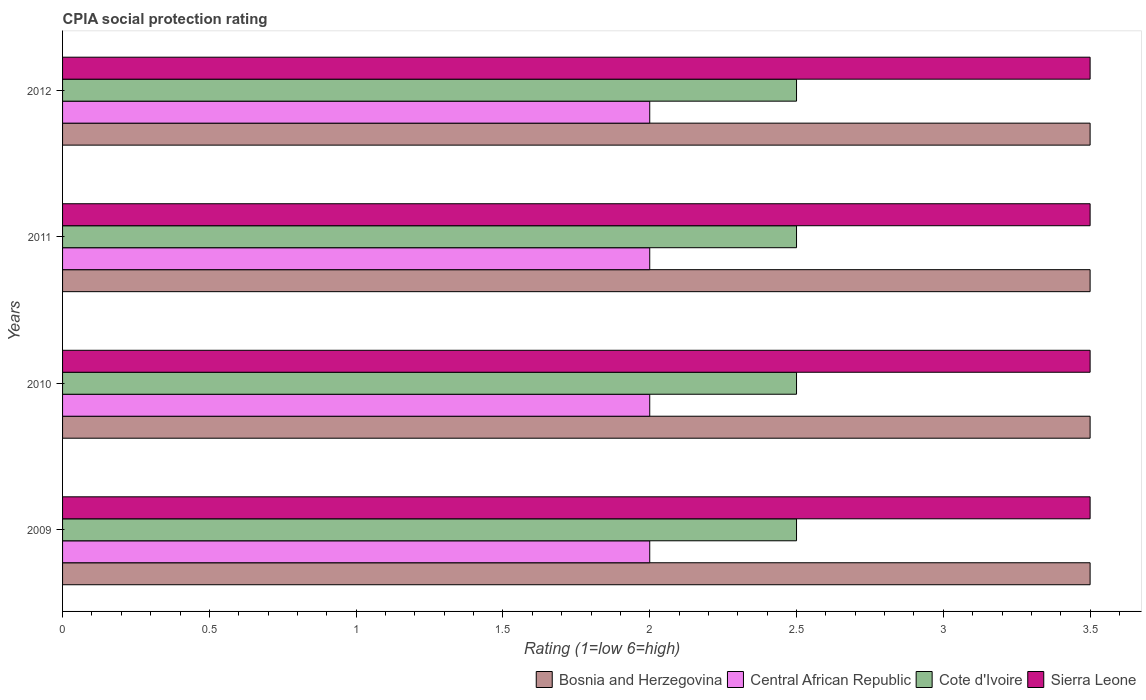Are the number of bars per tick equal to the number of legend labels?
Provide a succinct answer. Yes. Are the number of bars on each tick of the Y-axis equal?
Offer a terse response. Yes. How many bars are there on the 2nd tick from the bottom?
Provide a succinct answer. 4. Across all years, what is the maximum CPIA rating in Sierra Leone?
Your response must be concise. 3.5. Across all years, what is the minimum CPIA rating in Cote d'Ivoire?
Your answer should be compact. 2.5. In which year was the CPIA rating in Sierra Leone maximum?
Offer a terse response. 2009. What is the total CPIA rating in Bosnia and Herzegovina in the graph?
Your answer should be compact. 14. What is the difference between the CPIA rating in Cote d'Ivoire in 2010 and that in 2011?
Make the answer very short. 0. What is the difference between the CPIA rating in Sierra Leone in 2010 and the CPIA rating in Bosnia and Herzegovina in 2012?
Keep it short and to the point. 0. In the year 2009, what is the difference between the CPIA rating in Cote d'Ivoire and CPIA rating in Central African Republic?
Offer a very short reply. 0.5. In how many years, is the CPIA rating in Bosnia and Herzegovina greater than 1 ?
Your answer should be very brief. 4. Is the CPIA rating in Cote d'Ivoire in 2010 less than that in 2012?
Provide a short and direct response. No. Is the difference between the CPIA rating in Cote d'Ivoire in 2009 and 2010 greater than the difference between the CPIA rating in Central African Republic in 2009 and 2010?
Your response must be concise. No. What is the difference between the highest and the second highest CPIA rating in Cote d'Ivoire?
Keep it short and to the point. 0. What does the 1st bar from the top in 2012 represents?
Your answer should be very brief. Sierra Leone. What does the 3rd bar from the bottom in 2010 represents?
Offer a very short reply. Cote d'Ivoire. Is it the case that in every year, the sum of the CPIA rating in Central African Republic and CPIA rating in Sierra Leone is greater than the CPIA rating in Bosnia and Herzegovina?
Provide a succinct answer. Yes. Are all the bars in the graph horizontal?
Give a very brief answer. Yes. How many years are there in the graph?
Offer a terse response. 4. What is the difference between two consecutive major ticks on the X-axis?
Keep it short and to the point. 0.5. Are the values on the major ticks of X-axis written in scientific E-notation?
Your response must be concise. No. Does the graph contain any zero values?
Keep it short and to the point. No. How are the legend labels stacked?
Your answer should be compact. Horizontal. What is the title of the graph?
Your response must be concise. CPIA social protection rating. What is the label or title of the X-axis?
Your answer should be very brief. Rating (1=low 6=high). What is the Rating (1=low 6=high) in Cote d'Ivoire in 2009?
Your answer should be very brief. 2.5. What is the Rating (1=low 6=high) of Sierra Leone in 2009?
Your answer should be compact. 3.5. What is the Rating (1=low 6=high) in Bosnia and Herzegovina in 2010?
Provide a short and direct response. 3.5. What is the Rating (1=low 6=high) in Cote d'Ivoire in 2010?
Provide a succinct answer. 2.5. What is the Rating (1=low 6=high) of Cote d'Ivoire in 2011?
Make the answer very short. 2.5. What is the Rating (1=low 6=high) in Central African Republic in 2012?
Ensure brevity in your answer.  2. Across all years, what is the minimum Rating (1=low 6=high) of Bosnia and Herzegovina?
Give a very brief answer. 3.5. Across all years, what is the minimum Rating (1=low 6=high) of Central African Republic?
Keep it short and to the point. 2. Across all years, what is the minimum Rating (1=low 6=high) of Cote d'Ivoire?
Provide a succinct answer. 2.5. What is the total Rating (1=low 6=high) in Central African Republic in the graph?
Give a very brief answer. 8. What is the total Rating (1=low 6=high) in Cote d'Ivoire in the graph?
Keep it short and to the point. 10. What is the difference between the Rating (1=low 6=high) in Bosnia and Herzegovina in 2009 and that in 2010?
Provide a short and direct response. 0. What is the difference between the Rating (1=low 6=high) in Central African Republic in 2009 and that in 2010?
Your answer should be compact. 0. What is the difference between the Rating (1=low 6=high) of Cote d'Ivoire in 2009 and that in 2010?
Keep it short and to the point. 0. What is the difference between the Rating (1=low 6=high) of Sierra Leone in 2009 and that in 2010?
Provide a short and direct response. 0. What is the difference between the Rating (1=low 6=high) in Cote d'Ivoire in 2009 and that in 2011?
Ensure brevity in your answer.  0. What is the difference between the Rating (1=low 6=high) of Sierra Leone in 2009 and that in 2011?
Make the answer very short. 0. What is the difference between the Rating (1=low 6=high) of Central African Republic in 2009 and that in 2012?
Your response must be concise. 0. What is the difference between the Rating (1=low 6=high) of Cote d'Ivoire in 2009 and that in 2012?
Your answer should be very brief. 0. What is the difference between the Rating (1=low 6=high) of Cote d'Ivoire in 2010 and that in 2011?
Keep it short and to the point. 0. What is the difference between the Rating (1=low 6=high) of Cote d'Ivoire in 2010 and that in 2012?
Provide a succinct answer. 0. What is the difference between the Rating (1=low 6=high) of Sierra Leone in 2010 and that in 2012?
Ensure brevity in your answer.  0. What is the difference between the Rating (1=low 6=high) in Central African Republic in 2011 and that in 2012?
Your response must be concise. 0. What is the difference between the Rating (1=low 6=high) in Bosnia and Herzegovina in 2009 and the Rating (1=low 6=high) in Central African Republic in 2010?
Your response must be concise. 1.5. What is the difference between the Rating (1=low 6=high) in Bosnia and Herzegovina in 2009 and the Rating (1=low 6=high) in Cote d'Ivoire in 2010?
Your answer should be compact. 1. What is the difference between the Rating (1=low 6=high) of Central African Republic in 2009 and the Rating (1=low 6=high) of Sierra Leone in 2010?
Keep it short and to the point. -1.5. What is the difference between the Rating (1=low 6=high) in Bosnia and Herzegovina in 2009 and the Rating (1=low 6=high) in Sierra Leone in 2011?
Your response must be concise. 0. What is the difference between the Rating (1=low 6=high) in Central African Republic in 2009 and the Rating (1=low 6=high) in Sierra Leone in 2011?
Offer a very short reply. -1.5. What is the difference between the Rating (1=low 6=high) in Cote d'Ivoire in 2009 and the Rating (1=low 6=high) in Sierra Leone in 2011?
Keep it short and to the point. -1. What is the difference between the Rating (1=low 6=high) of Bosnia and Herzegovina in 2009 and the Rating (1=low 6=high) of Sierra Leone in 2012?
Provide a short and direct response. 0. What is the difference between the Rating (1=low 6=high) in Central African Republic in 2009 and the Rating (1=low 6=high) in Cote d'Ivoire in 2012?
Offer a terse response. -0.5. What is the difference between the Rating (1=low 6=high) in Cote d'Ivoire in 2009 and the Rating (1=low 6=high) in Sierra Leone in 2012?
Ensure brevity in your answer.  -1. What is the difference between the Rating (1=low 6=high) in Bosnia and Herzegovina in 2010 and the Rating (1=low 6=high) in Cote d'Ivoire in 2011?
Your answer should be compact. 1. What is the difference between the Rating (1=low 6=high) of Bosnia and Herzegovina in 2010 and the Rating (1=low 6=high) of Sierra Leone in 2011?
Your response must be concise. 0. What is the difference between the Rating (1=low 6=high) of Central African Republic in 2010 and the Rating (1=low 6=high) of Cote d'Ivoire in 2011?
Ensure brevity in your answer.  -0.5. What is the difference between the Rating (1=low 6=high) of Central African Republic in 2010 and the Rating (1=low 6=high) of Sierra Leone in 2011?
Your answer should be very brief. -1.5. What is the difference between the Rating (1=low 6=high) of Central African Republic in 2010 and the Rating (1=low 6=high) of Cote d'Ivoire in 2012?
Keep it short and to the point. -0.5. What is the difference between the Rating (1=low 6=high) of Bosnia and Herzegovina in 2011 and the Rating (1=low 6=high) of Central African Republic in 2012?
Make the answer very short. 1.5. What is the difference between the Rating (1=low 6=high) in Bosnia and Herzegovina in 2011 and the Rating (1=low 6=high) in Cote d'Ivoire in 2012?
Offer a very short reply. 1. What is the difference between the Rating (1=low 6=high) of Central African Republic in 2011 and the Rating (1=low 6=high) of Cote d'Ivoire in 2012?
Give a very brief answer. -0.5. What is the difference between the Rating (1=low 6=high) in Cote d'Ivoire in 2011 and the Rating (1=low 6=high) in Sierra Leone in 2012?
Provide a succinct answer. -1. What is the average Rating (1=low 6=high) of Central African Republic per year?
Your answer should be very brief. 2. In the year 2009, what is the difference between the Rating (1=low 6=high) in Bosnia and Herzegovina and Rating (1=low 6=high) in Central African Republic?
Provide a short and direct response. 1.5. In the year 2009, what is the difference between the Rating (1=low 6=high) in Bosnia and Herzegovina and Rating (1=low 6=high) in Sierra Leone?
Ensure brevity in your answer.  0. In the year 2009, what is the difference between the Rating (1=low 6=high) in Central African Republic and Rating (1=low 6=high) in Cote d'Ivoire?
Make the answer very short. -0.5. In the year 2009, what is the difference between the Rating (1=low 6=high) of Central African Republic and Rating (1=low 6=high) of Sierra Leone?
Your response must be concise. -1.5. In the year 2010, what is the difference between the Rating (1=low 6=high) of Bosnia and Herzegovina and Rating (1=low 6=high) of Central African Republic?
Provide a short and direct response. 1.5. In the year 2010, what is the difference between the Rating (1=low 6=high) in Bosnia and Herzegovina and Rating (1=low 6=high) in Cote d'Ivoire?
Offer a very short reply. 1. In the year 2010, what is the difference between the Rating (1=low 6=high) in Cote d'Ivoire and Rating (1=low 6=high) in Sierra Leone?
Make the answer very short. -1. In the year 2011, what is the difference between the Rating (1=low 6=high) of Bosnia and Herzegovina and Rating (1=low 6=high) of Central African Republic?
Ensure brevity in your answer.  1.5. In the year 2011, what is the difference between the Rating (1=low 6=high) in Bosnia and Herzegovina and Rating (1=low 6=high) in Cote d'Ivoire?
Provide a succinct answer. 1. In the year 2012, what is the difference between the Rating (1=low 6=high) of Bosnia and Herzegovina and Rating (1=low 6=high) of Central African Republic?
Ensure brevity in your answer.  1.5. In the year 2012, what is the difference between the Rating (1=low 6=high) of Central African Republic and Rating (1=low 6=high) of Sierra Leone?
Offer a terse response. -1.5. In the year 2012, what is the difference between the Rating (1=low 6=high) in Cote d'Ivoire and Rating (1=low 6=high) in Sierra Leone?
Make the answer very short. -1. What is the ratio of the Rating (1=low 6=high) in Bosnia and Herzegovina in 2009 to that in 2011?
Your answer should be very brief. 1. What is the ratio of the Rating (1=low 6=high) in Sierra Leone in 2009 to that in 2011?
Offer a very short reply. 1. What is the ratio of the Rating (1=low 6=high) in Central African Republic in 2010 to that in 2012?
Provide a short and direct response. 1. What is the ratio of the Rating (1=low 6=high) of Cote d'Ivoire in 2010 to that in 2012?
Offer a terse response. 1. What is the ratio of the Rating (1=low 6=high) of Sierra Leone in 2010 to that in 2012?
Your answer should be compact. 1. What is the ratio of the Rating (1=low 6=high) in Bosnia and Herzegovina in 2011 to that in 2012?
Provide a short and direct response. 1. What is the ratio of the Rating (1=low 6=high) of Cote d'Ivoire in 2011 to that in 2012?
Give a very brief answer. 1. What is the ratio of the Rating (1=low 6=high) of Sierra Leone in 2011 to that in 2012?
Your answer should be very brief. 1. What is the difference between the highest and the second highest Rating (1=low 6=high) of Central African Republic?
Keep it short and to the point. 0. What is the difference between the highest and the second highest Rating (1=low 6=high) of Cote d'Ivoire?
Offer a terse response. 0. What is the difference between the highest and the second highest Rating (1=low 6=high) in Sierra Leone?
Give a very brief answer. 0. What is the difference between the highest and the lowest Rating (1=low 6=high) in Central African Republic?
Keep it short and to the point. 0. 